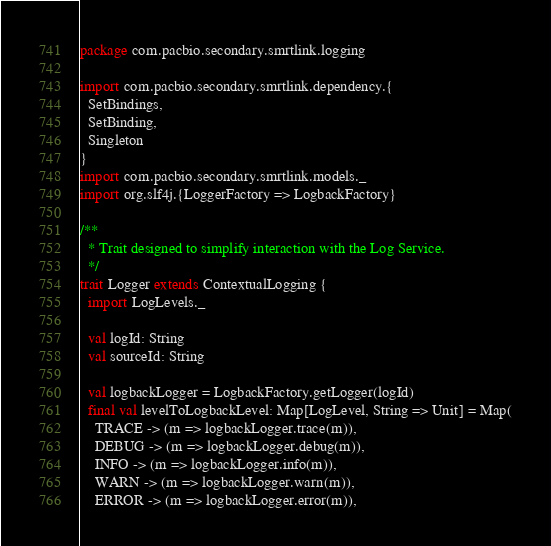Convert code to text. <code><loc_0><loc_0><loc_500><loc_500><_Scala_>package com.pacbio.secondary.smrtlink.logging

import com.pacbio.secondary.smrtlink.dependency.{
  SetBindings,
  SetBinding,
  Singleton
}
import com.pacbio.secondary.smrtlink.models._
import org.slf4j.{LoggerFactory => LogbackFactory}

/**
  * Trait designed to simplify interaction with the Log Service.
  */
trait Logger extends ContextualLogging {
  import LogLevels._

  val logId: String
  val sourceId: String

  val logbackLogger = LogbackFactory.getLogger(logId)
  final val levelToLogbackLevel: Map[LogLevel, String => Unit] = Map(
    TRACE -> (m => logbackLogger.trace(m)),
    DEBUG -> (m => logbackLogger.debug(m)),
    INFO -> (m => logbackLogger.info(m)),
    WARN -> (m => logbackLogger.warn(m)),
    ERROR -> (m => logbackLogger.error(m)),</code> 